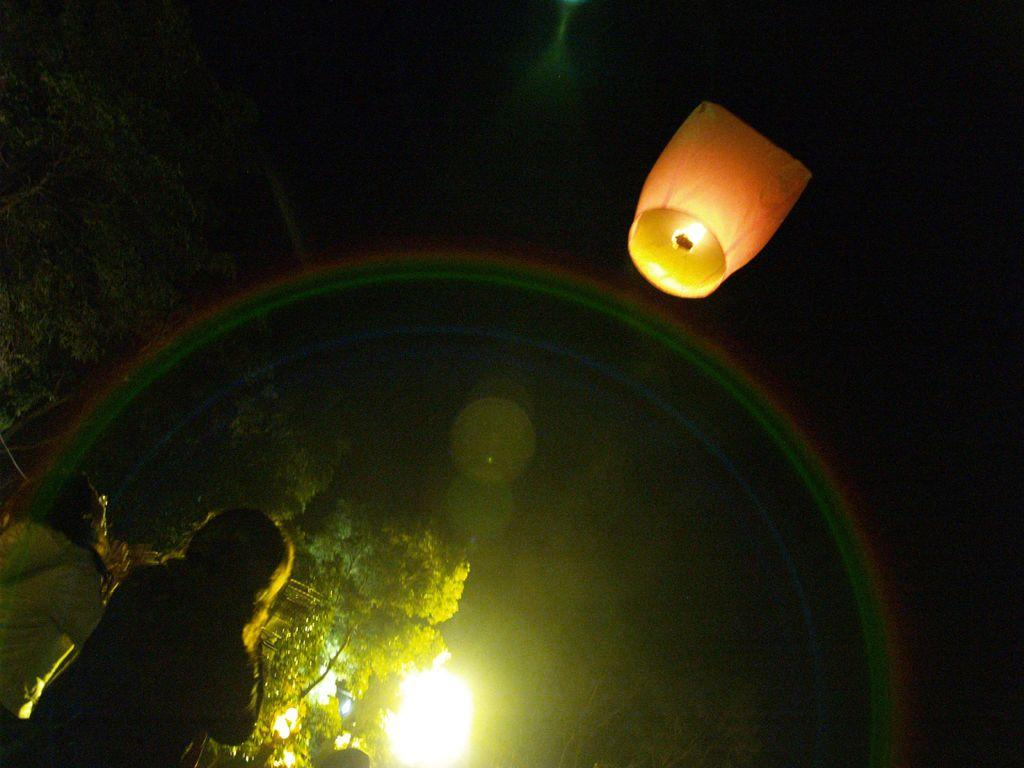How many people are present in the image? There are two persons in the image. What can be seen in the background of the image? There are trees in the image. Are there any artificial light sources visible in the image? Yes, there are lights in the image. What is the unusual object in the sky in the image? There is a parachute with a small fire lamp in the sky. What type of powder is being used by the persons in the image? There is no indication of any powder being used by the persons in the image. Can you see a pear hanging from one of the trees in the image? There is no pear visible in the image; only trees are present in the background. 